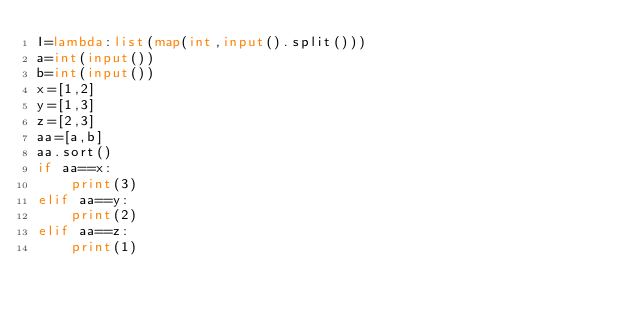<code> <loc_0><loc_0><loc_500><loc_500><_Python_>I=lambda:list(map(int,input().split()))
a=int(input())
b=int(input())
x=[1,2]
y=[1,3]
z=[2,3]
aa=[a,b]
aa.sort()
if aa==x:
    print(3)
elif aa==y:
    print(2)
elif aa==z:
    print(1)</code> 